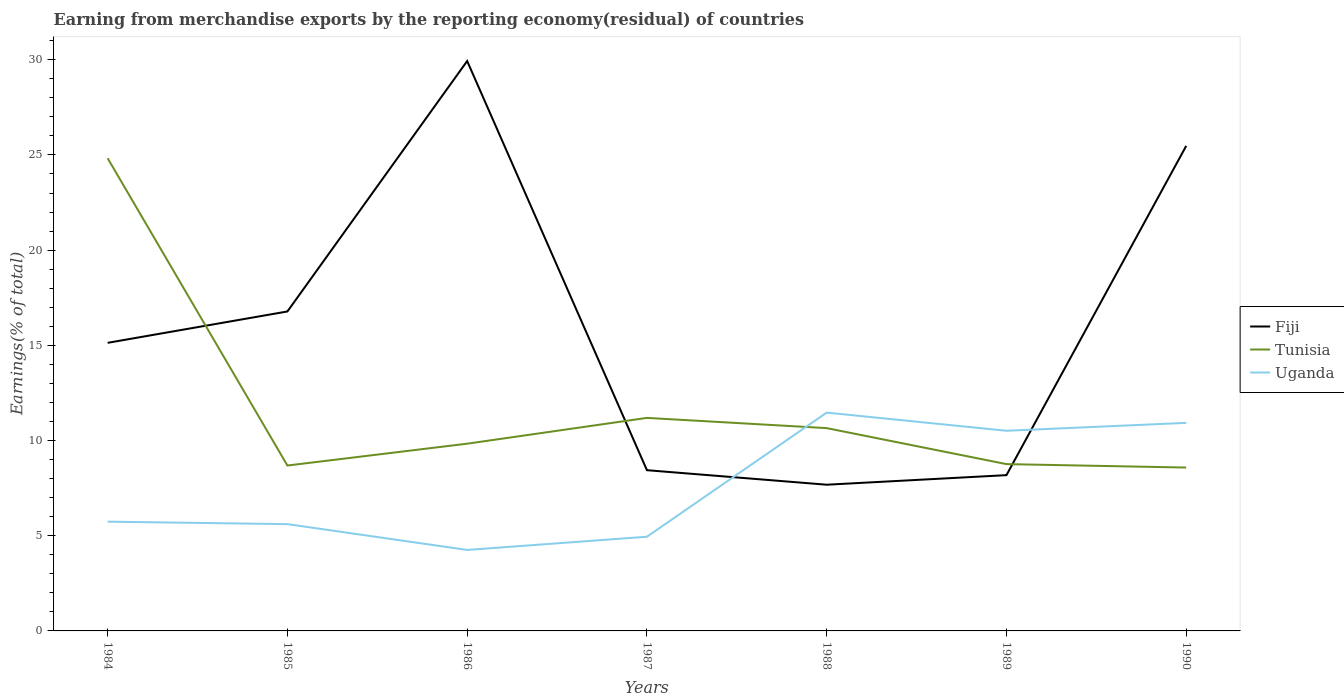How many different coloured lines are there?
Your response must be concise. 3. Does the line corresponding to Fiji intersect with the line corresponding to Tunisia?
Your response must be concise. Yes. Across all years, what is the maximum percentage of amount earned from merchandise exports in Tunisia?
Your response must be concise. 8.58. In which year was the percentage of amount earned from merchandise exports in Uganda maximum?
Provide a succinct answer. 1986. What is the total percentage of amount earned from merchandise exports in Fiji in the graph?
Your answer should be very brief. 7.45. What is the difference between the highest and the second highest percentage of amount earned from merchandise exports in Uganda?
Ensure brevity in your answer.  7.21. What is the difference between the highest and the lowest percentage of amount earned from merchandise exports in Uganda?
Offer a terse response. 3. Is the percentage of amount earned from merchandise exports in Fiji strictly greater than the percentage of amount earned from merchandise exports in Uganda over the years?
Keep it short and to the point. No. How many lines are there?
Give a very brief answer. 3. How many years are there in the graph?
Ensure brevity in your answer.  7. What is the difference between two consecutive major ticks on the Y-axis?
Offer a very short reply. 5. Does the graph contain any zero values?
Offer a very short reply. No. Does the graph contain grids?
Your response must be concise. No. Where does the legend appear in the graph?
Keep it short and to the point. Center right. How many legend labels are there?
Provide a short and direct response. 3. What is the title of the graph?
Your answer should be very brief. Earning from merchandise exports by the reporting economy(residual) of countries. Does "Malaysia" appear as one of the legend labels in the graph?
Ensure brevity in your answer.  No. What is the label or title of the Y-axis?
Ensure brevity in your answer.  Earnings(% of total). What is the Earnings(% of total) of Fiji in 1984?
Offer a terse response. 15.13. What is the Earnings(% of total) in Tunisia in 1984?
Make the answer very short. 24.83. What is the Earnings(% of total) in Uganda in 1984?
Make the answer very short. 5.74. What is the Earnings(% of total) of Fiji in 1985?
Offer a terse response. 16.78. What is the Earnings(% of total) of Tunisia in 1985?
Offer a terse response. 8.69. What is the Earnings(% of total) of Uganda in 1985?
Keep it short and to the point. 5.61. What is the Earnings(% of total) of Fiji in 1986?
Ensure brevity in your answer.  29.93. What is the Earnings(% of total) of Tunisia in 1986?
Your response must be concise. 9.83. What is the Earnings(% of total) in Uganda in 1986?
Keep it short and to the point. 4.25. What is the Earnings(% of total) in Fiji in 1987?
Your response must be concise. 8.44. What is the Earnings(% of total) of Tunisia in 1987?
Your response must be concise. 11.19. What is the Earnings(% of total) of Uganda in 1987?
Provide a succinct answer. 4.95. What is the Earnings(% of total) of Fiji in 1988?
Your response must be concise. 7.68. What is the Earnings(% of total) of Tunisia in 1988?
Your answer should be compact. 10.65. What is the Earnings(% of total) in Uganda in 1988?
Provide a succinct answer. 11.47. What is the Earnings(% of total) of Fiji in 1989?
Your answer should be compact. 8.18. What is the Earnings(% of total) of Tunisia in 1989?
Your answer should be very brief. 8.76. What is the Earnings(% of total) of Uganda in 1989?
Offer a very short reply. 10.51. What is the Earnings(% of total) of Fiji in 1990?
Your response must be concise. 25.48. What is the Earnings(% of total) of Tunisia in 1990?
Make the answer very short. 8.58. What is the Earnings(% of total) of Uganda in 1990?
Give a very brief answer. 10.93. Across all years, what is the maximum Earnings(% of total) of Fiji?
Your response must be concise. 29.93. Across all years, what is the maximum Earnings(% of total) of Tunisia?
Your answer should be compact. 24.83. Across all years, what is the maximum Earnings(% of total) in Uganda?
Ensure brevity in your answer.  11.47. Across all years, what is the minimum Earnings(% of total) in Fiji?
Give a very brief answer. 7.68. Across all years, what is the minimum Earnings(% of total) of Tunisia?
Your answer should be compact. 8.58. Across all years, what is the minimum Earnings(% of total) of Uganda?
Ensure brevity in your answer.  4.25. What is the total Earnings(% of total) of Fiji in the graph?
Provide a succinct answer. 111.63. What is the total Earnings(% of total) of Tunisia in the graph?
Your answer should be compact. 82.53. What is the total Earnings(% of total) in Uganda in the graph?
Provide a succinct answer. 53.46. What is the difference between the Earnings(% of total) of Fiji in 1984 and that in 1985?
Ensure brevity in your answer.  -1.65. What is the difference between the Earnings(% of total) in Tunisia in 1984 and that in 1985?
Make the answer very short. 16.14. What is the difference between the Earnings(% of total) of Uganda in 1984 and that in 1985?
Offer a very short reply. 0.13. What is the difference between the Earnings(% of total) in Fiji in 1984 and that in 1986?
Offer a terse response. -14.8. What is the difference between the Earnings(% of total) in Tunisia in 1984 and that in 1986?
Offer a very short reply. 14.99. What is the difference between the Earnings(% of total) in Uganda in 1984 and that in 1986?
Ensure brevity in your answer.  1.49. What is the difference between the Earnings(% of total) of Fiji in 1984 and that in 1987?
Provide a short and direct response. 6.69. What is the difference between the Earnings(% of total) in Tunisia in 1984 and that in 1987?
Keep it short and to the point. 13.64. What is the difference between the Earnings(% of total) in Uganda in 1984 and that in 1987?
Give a very brief answer. 0.79. What is the difference between the Earnings(% of total) of Fiji in 1984 and that in 1988?
Offer a very short reply. 7.45. What is the difference between the Earnings(% of total) in Tunisia in 1984 and that in 1988?
Your answer should be very brief. 14.18. What is the difference between the Earnings(% of total) of Uganda in 1984 and that in 1988?
Your response must be concise. -5.73. What is the difference between the Earnings(% of total) in Fiji in 1984 and that in 1989?
Give a very brief answer. 6.95. What is the difference between the Earnings(% of total) in Tunisia in 1984 and that in 1989?
Provide a succinct answer. 16.07. What is the difference between the Earnings(% of total) in Uganda in 1984 and that in 1989?
Your answer should be very brief. -4.77. What is the difference between the Earnings(% of total) of Fiji in 1984 and that in 1990?
Offer a very short reply. -10.35. What is the difference between the Earnings(% of total) of Tunisia in 1984 and that in 1990?
Your answer should be very brief. 16.25. What is the difference between the Earnings(% of total) of Uganda in 1984 and that in 1990?
Your response must be concise. -5.19. What is the difference between the Earnings(% of total) in Fiji in 1985 and that in 1986?
Your answer should be compact. -13.15. What is the difference between the Earnings(% of total) in Tunisia in 1985 and that in 1986?
Your response must be concise. -1.15. What is the difference between the Earnings(% of total) of Uganda in 1985 and that in 1986?
Provide a succinct answer. 1.36. What is the difference between the Earnings(% of total) in Fiji in 1985 and that in 1987?
Give a very brief answer. 8.34. What is the difference between the Earnings(% of total) in Tunisia in 1985 and that in 1987?
Keep it short and to the point. -2.5. What is the difference between the Earnings(% of total) in Uganda in 1985 and that in 1987?
Your answer should be compact. 0.66. What is the difference between the Earnings(% of total) in Fiji in 1985 and that in 1988?
Give a very brief answer. 9.1. What is the difference between the Earnings(% of total) in Tunisia in 1985 and that in 1988?
Offer a very short reply. -1.96. What is the difference between the Earnings(% of total) of Uganda in 1985 and that in 1988?
Your response must be concise. -5.86. What is the difference between the Earnings(% of total) in Fiji in 1985 and that in 1989?
Your answer should be compact. 8.6. What is the difference between the Earnings(% of total) of Tunisia in 1985 and that in 1989?
Ensure brevity in your answer.  -0.07. What is the difference between the Earnings(% of total) of Uganda in 1985 and that in 1989?
Your answer should be compact. -4.9. What is the difference between the Earnings(% of total) in Fiji in 1985 and that in 1990?
Ensure brevity in your answer.  -8.7. What is the difference between the Earnings(% of total) in Tunisia in 1985 and that in 1990?
Your answer should be compact. 0.11. What is the difference between the Earnings(% of total) of Uganda in 1985 and that in 1990?
Give a very brief answer. -5.32. What is the difference between the Earnings(% of total) of Fiji in 1986 and that in 1987?
Make the answer very short. 21.49. What is the difference between the Earnings(% of total) of Tunisia in 1986 and that in 1987?
Give a very brief answer. -1.36. What is the difference between the Earnings(% of total) of Uganda in 1986 and that in 1987?
Offer a very short reply. -0.69. What is the difference between the Earnings(% of total) of Fiji in 1986 and that in 1988?
Give a very brief answer. 22.25. What is the difference between the Earnings(% of total) in Tunisia in 1986 and that in 1988?
Give a very brief answer. -0.82. What is the difference between the Earnings(% of total) in Uganda in 1986 and that in 1988?
Keep it short and to the point. -7.21. What is the difference between the Earnings(% of total) of Fiji in 1986 and that in 1989?
Your answer should be compact. 21.75. What is the difference between the Earnings(% of total) in Tunisia in 1986 and that in 1989?
Your answer should be compact. 1.07. What is the difference between the Earnings(% of total) in Uganda in 1986 and that in 1989?
Provide a short and direct response. -6.26. What is the difference between the Earnings(% of total) in Fiji in 1986 and that in 1990?
Keep it short and to the point. 4.46. What is the difference between the Earnings(% of total) in Tunisia in 1986 and that in 1990?
Give a very brief answer. 1.25. What is the difference between the Earnings(% of total) in Uganda in 1986 and that in 1990?
Keep it short and to the point. -6.67. What is the difference between the Earnings(% of total) in Fiji in 1987 and that in 1988?
Your answer should be very brief. 0.76. What is the difference between the Earnings(% of total) of Tunisia in 1987 and that in 1988?
Ensure brevity in your answer.  0.54. What is the difference between the Earnings(% of total) in Uganda in 1987 and that in 1988?
Your answer should be very brief. -6.52. What is the difference between the Earnings(% of total) of Fiji in 1987 and that in 1989?
Give a very brief answer. 0.26. What is the difference between the Earnings(% of total) of Tunisia in 1987 and that in 1989?
Keep it short and to the point. 2.43. What is the difference between the Earnings(% of total) of Uganda in 1987 and that in 1989?
Offer a terse response. -5.57. What is the difference between the Earnings(% of total) in Fiji in 1987 and that in 1990?
Keep it short and to the point. -17.03. What is the difference between the Earnings(% of total) in Tunisia in 1987 and that in 1990?
Offer a very short reply. 2.61. What is the difference between the Earnings(% of total) in Uganda in 1987 and that in 1990?
Provide a succinct answer. -5.98. What is the difference between the Earnings(% of total) of Fiji in 1988 and that in 1989?
Provide a succinct answer. -0.5. What is the difference between the Earnings(% of total) in Tunisia in 1988 and that in 1989?
Keep it short and to the point. 1.89. What is the difference between the Earnings(% of total) in Uganda in 1988 and that in 1989?
Your response must be concise. 0.95. What is the difference between the Earnings(% of total) of Fiji in 1988 and that in 1990?
Ensure brevity in your answer.  -17.8. What is the difference between the Earnings(% of total) of Tunisia in 1988 and that in 1990?
Make the answer very short. 2.07. What is the difference between the Earnings(% of total) of Uganda in 1988 and that in 1990?
Ensure brevity in your answer.  0.54. What is the difference between the Earnings(% of total) of Fiji in 1989 and that in 1990?
Provide a succinct answer. -17.29. What is the difference between the Earnings(% of total) of Tunisia in 1989 and that in 1990?
Offer a very short reply. 0.18. What is the difference between the Earnings(% of total) of Uganda in 1989 and that in 1990?
Offer a very short reply. -0.42. What is the difference between the Earnings(% of total) of Fiji in 1984 and the Earnings(% of total) of Tunisia in 1985?
Make the answer very short. 6.44. What is the difference between the Earnings(% of total) in Fiji in 1984 and the Earnings(% of total) in Uganda in 1985?
Ensure brevity in your answer.  9.52. What is the difference between the Earnings(% of total) of Tunisia in 1984 and the Earnings(% of total) of Uganda in 1985?
Your answer should be very brief. 19.22. What is the difference between the Earnings(% of total) of Fiji in 1984 and the Earnings(% of total) of Tunisia in 1986?
Your answer should be compact. 5.3. What is the difference between the Earnings(% of total) of Fiji in 1984 and the Earnings(% of total) of Uganda in 1986?
Your answer should be very brief. 10.88. What is the difference between the Earnings(% of total) in Tunisia in 1984 and the Earnings(% of total) in Uganda in 1986?
Your answer should be very brief. 20.58. What is the difference between the Earnings(% of total) in Fiji in 1984 and the Earnings(% of total) in Tunisia in 1987?
Offer a terse response. 3.94. What is the difference between the Earnings(% of total) of Fiji in 1984 and the Earnings(% of total) of Uganda in 1987?
Your answer should be compact. 10.18. What is the difference between the Earnings(% of total) of Tunisia in 1984 and the Earnings(% of total) of Uganda in 1987?
Give a very brief answer. 19.88. What is the difference between the Earnings(% of total) of Fiji in 1984 and the Earnings(% of total) of Tunisia in 1988?
Ensure brevity in your answer.  4.48. What is the difference between the Earnings(% of total) in Fiji in 1984 and the Earnings(% of total) in Uganda in 1988?
Offer a terse response. 3.66. What is the difference between the Earnings(% of total) of Tunisia in 1984 and the Earnings(% of total) of Uganda in 1988?
Provide a succinct answer. 13.36. What is the difference between the Earnings(% of total) in Fiji in 1984 and the Earnings(% of total) in Tunisia in 1989?
Your answer should be compact. 6.37. What is the difference between the Earnings(% of total) in Fiji in 1984 and the Earnings(% of total) in Uganda in 1989?
Your answer should be very brief. 4.62. What is the difference between the Earnings(% of total) in Tunisia in 1984 and the Earnings(% of total) in Uganda in 1989?
Offer a very short reply. 14.32. What is the difference between the Earnings(% of total) of Fiji in 1984 and the Earnings(% of total) of Tunisia in 1990?
Ensure brevity in your answer.  6.55. What is the difference between the Earnings(% of total) in Fiji in 1984 and the Earnings(% of total) in Uganda in 1990?
Offer a very short reply. 4.2. What is the difference between the Earnings(% of total) in Tunisia in 1984 and the Earnings(% of total) in Uganda in 1990?
Give a very brief answer. 13.9. What is the difference between the Earnings(% of total) in Fiji in 1985 and the Earnings(% of total) in Tunisia in 1986?
Ensure brevity in your answer.  6.94. What is the difference between the Earnings(% of total) in Fiji in 1985 and the Earnings(% of total) in Uganda in 1986?
Provide a succinct answer. 12.53. What is the difference between the Earnings(% of total) in Tunisia in 1985 and the Earnings(% of total) in Uganda in 1986?
Your response must be concise. 4.43. What is the difference between the Earnings(% of total) in Fiji in 1985 and the Earnings(% of total) in Tunisia in 1987?
Provide a succinct answer. 5.59. What is the difference between the Earnings(% of total) in Fiji in 1985 and the Earnings(% of total) in Uganda in 1987?
Give a very brief answer. 11.83. What is the difference between the Earnings(% of total) of Tunisia in 1985 and the Earnings(% of total) of Uganda in 1987?
Your response must be concise. 3.74. What is the difference between the Earnings(% of total) in Fiji in 1985 and the Earnings(% of total) in Tunisia in 1988?
Your answer should be very brief. 6.13. What is the difference between the Earnings(% of total) in Fiji in 1985 and the Earnings(% of total) in Uganda in 1988?
Give a very brief answer. 5.31. What is the difference between the Earnings(% of total) of Tunisia in 1985 and the Earnings(% of total) of Uganda in 1988?
Offer a terse response. -2.78. What is the difference between the Earnings(% of total) of Fiji in 1985 and the Earnings(% of total) of Tunisia in 1989?
Keep it short and to the point. 8.02. What is the difference between the Earnings(% of total) in Fiji in 1985 and the Earnings(% of total) in Uganda in 1989?
Give a very brief answer. 6.27. What is the difference between the Earnings(% of total) of Tunisia in 1985 and the Earnings(% of total) of Uganda in 1989?
Make the answer very short. -1.83. What is the difference between the Earnings(% of total) in Fiji in 1985 and the Earnings(% of total) in Tunisia in 1990?
Your answer should be compact. 8.2. What is the difference between the Earnings(% of total) of Fiji in 1985 and the Earnings(% of total) of Uganda in 1990?
Provide a succinct answer. 5.85. What is the difference between the Earnings(% of total) of Tunisia in 1985 and the Earnings(% of total) of Uganda in 1990?
Offer a very short reply. -2.24. What is the difference between the Earnings(% of total) of Fiji in 1986 and the Earnings(% of total) of Tunisia in 1987?
Your answer should be very brief. 18.74. What is the difference between the Earnings(% of total) of Fiji in 1986 and the Earnings(% of total) of Uganda in 1987?
Provide a short and direct response. 24.99. What is the difference between the Earnings(% of total) in Tunisia in 1986 and the Earnings(% of total) in Uganda in 1987?
Keep it short and to the point. 4.89. What is the difference between the Earnings(% of total) in Fiji in 1986 and the Earnings(% of total) in Tunisia in 1988?
Your answer should be compact. 19.28. What is the difference between the Earnings(% of total) in Fiji in 1986 and the Earnings(% of total) in Uganda in 1988?
Your answer should be very brief. 18.47. What is the difference between the Earnings(% of total) in Tunisia in 1986 and the Earnings(% of total) in Uganda in 1988?
Your answer should be compact. -1.63. What is the difference between the Earnings(% of total) in Fiji in 1986 and the Earnings(% of total) in Tunisia in 1989?
Offer a very short reply. 21.17. What is the difference between the Earnings(% of total) of Fiji in 1986 and the Earnings(% of total) of Uganda in 1989?
Provide a short and direct response. 19.42. What is the difference between the Earnings(% of total) in Tunisia in 1986 and the Earnings(% of total) in Uganda in 1989?
Your answer should be very brief. -0.68. What is the difference between the Earnings(% of total) in Fiji in 1986 and the Earnings(% of total) in Tunisia in 1990?
Offer a terse response. 21.35. What is the difference between the Earnings(% of total) of Fiji in 1986 and the Earnings(% of total) of Uganda in 1990?
Your answer should be compact. 19.01. What is the difference between the Earnings(% of total) in Tunisia in 1986 and the Earnings(% of total) in Uganda in 1990?
Give a very brief answer. -1.09. What is the difference between the Earnings(% of total) in Fiji in 1987 and the Earnings(% of total) in Tunisia in 1988?
Your answer should be compact. -2.21. What is the difference between the Earnings(% of total) in Fiji in 1987 and the Earnings(% of total) in Uganda in 1988?
Offer a very short reply. -3.02. What is the difference between the Earnings(% of total) of Tunisia in 1987 and the Earnings(% of total) of Uganda in 1988?
Your answer should be very brief. -0.28. What is the difference between the Earnings(% of total) in Fiji in 1987 and the Earnings(% of total) in Tunisia in 1989?
Your answer should be compact. -0.32. What is the difference between the Earnings(% of total) of Fiji in 1987 and the Earnings(% of total) of Uganda in 1989?
Make the answer very short. -2.07. What is the difference between the Earnings(% of total) in Tunisia in 1987 and the Earnings(% of total) in Uganda in 1989?
Make the answer very short. 0.68. What is the difference between the Earnings(% of total) in Fiji in 1987 and the Earnings(% of total) in Tunisia in 1990?
Provide a short and direct response. -0.14. What is the difference between the Earnings(% of total) of Fiji in 1987 and the Earnings(% of total) of Uganda in 1990?
Provide a short and direct response. -2.49. What is the difference between the Earnings(% of total) in Tunisia in 1987 and the Earnings(% of total) in Uganda in 1990?
Make the answer very short. 0.26. What is the difference between the Earnings(% of total) in Fiji in 1988 and the Earnings(% of total) in Tunisia in 1989?
Make the answer very short. -1.08. What is the difference between the Earnings(% of total) in Fiji in 1988 and the Earnings(% of total) in Uganda in 1989?
Make the answer very short. -2.83. What is the difference between the Earnings(% of total) in Tunisia in 1988 and the Earnings(% of total) in Uganda in 1989?
Keep it short and to the point. 0.14. What is the difference between the Earnings(% of total) in Fiji in 1988 and the Earnings(% of total) in Tunisia in 1990?
Keep it short and to the point. -0.9. What is the difference between the Earnings(% of total) in Fiji in 1988 and the Earnings(% of total) in Uganda in 1990?
Provide a succinct answer. -3.25. What is the difference between the Earnings(% of total) of Tunisia in 1988 and the Earnings(% of total) of Uganda in 1990?
Keep it short and to the point. -0.28. What is the difference between the Earnings(% of total) in Fiji in 1989 and the Earnings(% of total) in Tunisia in 1990?
Your answer should be very brief. -0.4. What is the difference between the Earnings(% of total) of Fiji in 1989 and the Earnings(% of total) of Uganda in 1990?
Your answer should be compact. -2.75. What is the difference between the Earnings(% of total) of Tunisia in 1989 and the Earnings(% of total) of Uganda in 1990?
Offer a terse response. -2.17. What is the average Earnings(% of total) in Fiji per year?
Your answer should be very brief. 15.95. What is the average Earnings(% of total) of Tunisia per year?
Offer a very short reply. 11.79. What is the average Earnings(% of total) in Uganda per year?
Your answer should be very brief. 7.64. In the year 1984, what is the difference between the Earnings(% of total) of Fiji and Earnings(% of total) of Tunisia?
Provide a short and direct response. -9.7. In the year 1984, what is the difference between the Earnings(% of total) in Fiji and Earnings(% of total) in Uganda?
Your answer should be very brief. 9.39. In the year 1984, what is the difference between the Earnings(% of total) in Tunisia and Earnings(% of total) in Uganda?
Provide a short and direct response. 19.09. In the year 1985, what is the difference between the Earnings(% of total) of Fiji and Earnings(% of total) of Tunisia?
Give a very brief answer. 8.09. In the year 1985, what is the difference between the Earnings(% of total) of Fiji and Earnings(% of total) of Uganda?
Your response must be concise. 11.17. In the year 1985, what is the difference between the Earnings(% of total) in Tunisia and Earnings(% of total) in Uganda?
Make the answer very short. 3.08. In the year 1986, what is the difference between the Earnings(% of total) in Fiji and Earnings(% of total) in Tunisia?
Make the answer very short. 20.1. In the year 1986, what is the difference between the Earnings(% of total) of Fiji and Earnings(% of total) of Uganda?
Your answer should be compact. 25.68. In the year 1986, what is the difference between the Earnings(% of total) in Tunisia and Earnings(% of total) in Uganda?
Provide a short and direct response. 5.58. In the year 1987, what is the difference between the Earnings(% of total) in Fiji and Earnings(% of total) in Tunisia?
Your answer should be very brief. -2.75. In the year 1987, what is the difference between the Earnings(% of total) in Fiji and Earnings(% of total) in Uganda?
Give a very brief answer. 3.5. In the year 1987, what is the difference between the Earnings(% of total) of Tunisia and Earnings(% of total) of Uganda?
Ensure brevity in your answer.  6.24. In the year 1988, what is the difference between the Earnings(% of total) in Fiji and Earnings(% of total) in Tunisia?
Give a very brief answer. -2.97. In the year 1988, what is the difference between the Earnings(% of total) of Fiji and Earnings(% of total) of Uganda?
Give a very brief answer. -3.79. In the year 1988, what is the difference between the Earnings(% of total) of Tunisia and Earnings(% of total) of Uganda?
Make the answer very short. -0.82. In the year 1989, what is the difference between the Earnings(% of total) in Fiji and Earnings(% of total) in Tunisia?
Keep it short and to the point. -0.58. In the year 1989, what is the difference between the Earnings(% of total) in Fiji and Earnings(% of total) in Uganda?
Offer a very short reply. -2.33. In the year 1989, what is the difference between the Earnings(% of total) in Tunisia and Earnings(% of total) in Uganda?
Keep it short and to the point. -1.75. In the year 1990, what is the difference between the Earnings(% of total) of Fiji and Earnings(% of total) of Tunisia?
Ensure brevity in your answer.  16.9. In the year 1990, what is the difference between the Earnings(% of total) in Fiji and Earnings(% of total) in Uganda?
Offer a terse response. 14.55. In the year 1990, what is the difference between the Earnings(% of total) of Tunisia and Earnings(% of total) of Uganda?
Make the answer very short. -2.35. What is the ratio of the Earnings(% of total) of Fiji in 1984 to that in 1985?
Your answer should be very brief. 0.9. What is the ratio of the Earnings(% of total) in Tunisia in 1984 to that in 1985?
Keep it short and to the point. 2.86. What is the ratio of the Earnings(% of total) of Uganda in 1984 to that in 1985?
Provide a short and direct response. 1.02. What is the ratio of the Earnings(% of total) of Fiji in 1984 to that in 1986?
Your response must be concise. 0.51. What is the ratio of the Earnings(% of total) in Tunisia in 1984 to that in 1986?
Keep it short and to the point. 2.52. What is the ratio of the Earnings(% of total) of Uganda in 1984 to that in 1986?
Give a very brief answer. 1.35. What is the ratio of the Earnings(% of total) in Fiji in 1984 to that in 1987?
Ensure brevity in your answer.  1.79. What is the ratio of the Earnings(% of total) in Tunisia in 1984 to that in 1987?
Offer a terse response. 2.22. What is the ratio of the Earnings(% of total) in Uganda in 1984 to that in 1987?
Provide a short and direct response. 1.16. What is the ratio of the Earnings(% of total) of Fiji in 1984 to that in 1988?
Provide a short and direct response. 1.97. What is the ratio of the Earnings(% of total) of Tunisia in 1984 to that in 1988?
Your answer should be compact. 2.33. What is the ratio of the Earnings(% of total) in Uganda in 1984 to that in 1988?
Ensure brevity in your answer.  0.5. What is the ratio of the Earnings(% of total) of Fiji in 1984 to that in 1989?
Keep it short and to the point. 1.85. What is the ratio of the Earnings(% of total) of Tunisia in 1984 to that in 1989?
Keep it short and to the point. 2.83. What is the ratio of the Earnings(% of total) of Uganda in 1984 to that in 1989?
Provide a succinct answer. 0.55. What is the ratio of the Earnings(% of total) in Fiji in 1984 to that in 1990?
Provide a short and direct response. 0.59. What is the ratio of the Earnings(% of total) in Tunisia in 1984 to that in 1990?
Ensure brevity in your answer.  2.89. What is the ratio of the Earnings(% of total) of Uganda in 1984 to that in 1990?
Provide a succinct answer. 0.53. What is the ratio of the Earnings(% of total) in Fiji in 1985 to that in 1986?
Keep it short and to the point. 0.56. What is the ratio of the Earnings(% of total) of Tunisia in 1985 to that in 1986?
Provide a succinct answer. 0.88. What is the ratio of the Earnings(% of total) in Uganda in 1985 to that in 1986?
Ensure brevity in your answer.  1.32. What is the ratio of the Earnings(% of total) in Fiji in 1985 to that in 1987?
Offer a very short reply. 1.99. What is the ratio of the Earnings(% of total) of Tunisia in 1985 to that in 1987?
Ensure brevity in your answer.  0.78. What is the ratio of the Earnings(% of total) in Uganda in 1985 to that in 1987?
Your answer should be compact. 1.13. What is the ratio of the Earnings(% of total) of Fiji in 1985 to that in 1988?
Make the answer very short. 2.18. What is the ratio of the Earnings(% of total) in Tunisia in 1985 to that in 1988?
Provide a succinct answer. 0.82. What is the ratio of the Earnings(% of total) of Uganda in 1985 to that in 1988?
Your response must be concise. 0.49. What is the ratio of the Earnings(% of total) in Fiji in 1985 to that in 1989?
Your answer should be very brief. 2.05. What is the ratio of the Earnings(% of total) in Tunisia in 1985 to that in 1989?
Offer a terse response. 0.99. What is the ratio of the Earnings(% of total) in Uganda in 1985 to that in 1989?
Your response must be concise. 0.53. What is the ratio of the Earnings(% of total) of Fiji in 1985 to that in 1990?
Offer a terse response. 0.66. What is the ratio of the Earnings(% of total) in Tunisia in 1985 to that in 1990?
Ensure brevity in your answer.  1.01. What is the ratio of the Earnings(% of total) of Uganda in 1985 to that in 1990?
Give a very brief answer. 0.51. What is the ratio of the Earnings(% of total) of Fiji in 1986 to that in 1987?
Make the answer very short. 3.55. What is the ratio of the Earnings(% of total) of Tunisia in 1986 to that in 1987?
Offer a very short reply. 0.88. What is the ratio of the Earnings(% of total) in Uganda in 1986 to that in 1987?
Give a very brief answer. 0.86. What is the ratio of the Earnings(% of total) in Fiji in 1986 to that in 1988?
Your answer should be very brief. 3.9. What is the ratio of the Earnings(% of total) of Tunisia in 1986 to that in 1988?
Provide a short and direct response. 0.92. What is the ratio of the Earnings(% of total) of Uganda in 1986 to that in 1988?
Give a very brief answer. 0.37. What is the ratio of the Earnings(% of total) in Fiji in 1986 to that in 1989?
Keep it short and to the point. 3.66. What is the ratio of the Earnings(% of total) of Tunisia in 1986 to that in 1989?
Make the answer very short. 1.12. What is the ratio of the Earnings(% of total) of Uganda in 1986 to that in 1989?
Your response must be concise. 0.4. What is the ratio of the Earnings(% of total) in Fiji in 1986 to that in 1990?
Ensure brevity in your answer.  1.17. What is the ratio of the Earnings(% of total) in Tunisia in 1986 to that in 1990?
Your answer should be very brief. 1.15. What is the ratio of the Earnings(% of total) of Uganda in 1986 to that in 1990?
Make the answer very short. 0.39. What is the ratio of the Earnings(% of total) of Fiji in 1987 to that in 1988?
Provide a short and direct response. 1.1. What is the ratio of the Earnings(% of total) in Tunisia in 1987 to that in 1988?
Offer a very short reply. 1.05. What is the ratio of the Earnings(% of total) of Uganda in 1987 to that in 1988?
Offer a terse response. 0.43. What is the ratio of the Earnings(% of total) of Fiji in 1987 to that in 1989?
Your answer should be very brief. 1.03. What is the ratio of the Earnings(% of total) of Tunisia in 1987 to that in 1989?
Keep it short and to the point. 1.28. What is the ratio of the Earnings(% of total) of Uganda in 1987 to that in 1989?
Give a very brief answer. 0.47. What is the ratio of the Earnings(% of total) in Fiji in 1987 to that in 1990?
Offer a terse response. 0.33. What is the ratio of the Earnings(% of total) in Tunisia in 1987 to that in 1990?
Offer a very short reply. 1.3. What is the ratio of the Earnings(% of total) in Uganda in 1987 to that in 1990?
Offer a very short reply. 0.45. What is the ratio of the Earnings(% of total) of Fiji in 1988 to that in 1989?
Ensure brevity in your answer.  0.94. What is the ratio of the Earnings(% of total) in Tunisia in 1988 to that in 1989?
Provide a short and direct response. 1.22. What is the ratio of the Earnings(% of total) in Uganda in 1988 to that in 1989?
Ensure brevity in your answer.  1.09. What is the ratio of the Earnings(% of total) in Fiji in 1988 to that in 1990?
Your answer should be very brief. 0.3. What is the ratio of the Earnings(% of total) in Tunisia in 1988 to that in 1990?
Offer a terse response. 1.24. What is the ratio of the Earnings(% of total) in Uganda in 1988 to that in 1990?
Give a very brief answer. 1.05. What is the ratio of the Earnings(% of total) of Fiji in 1989 to that in 1990?
Keep it short and to the point. 0.32. What is the ratio of the Earnings(% of total) of Tunisia in 1989 to that in 1990?
Your answer should be compact. 1.02. What is the difference between the highest and the second highest Earnings(% of total) of Fiji?
Your response must be concise. 4.46. What is the difference between the highest and the second highest Earnings(% of total) of Tunisia?
Keep it short and to the point. 13.64. What is the difference between the highest and the second highest Earnings(% of total) of Uganda?
Keep it short and to the point. 0.54. What is the difference between the highest and the lowest Earnings(% of total) of Fiji?
Your answer should be compact. 22.25. What is the difference between the highest and the lowest Earnings(% of total) in Tunisia?
Offer a terse response. 16.25. What is the difference between the highest and the lowest Earnings(% of total) of Uganda?
Offer a terse response. 7.21. 